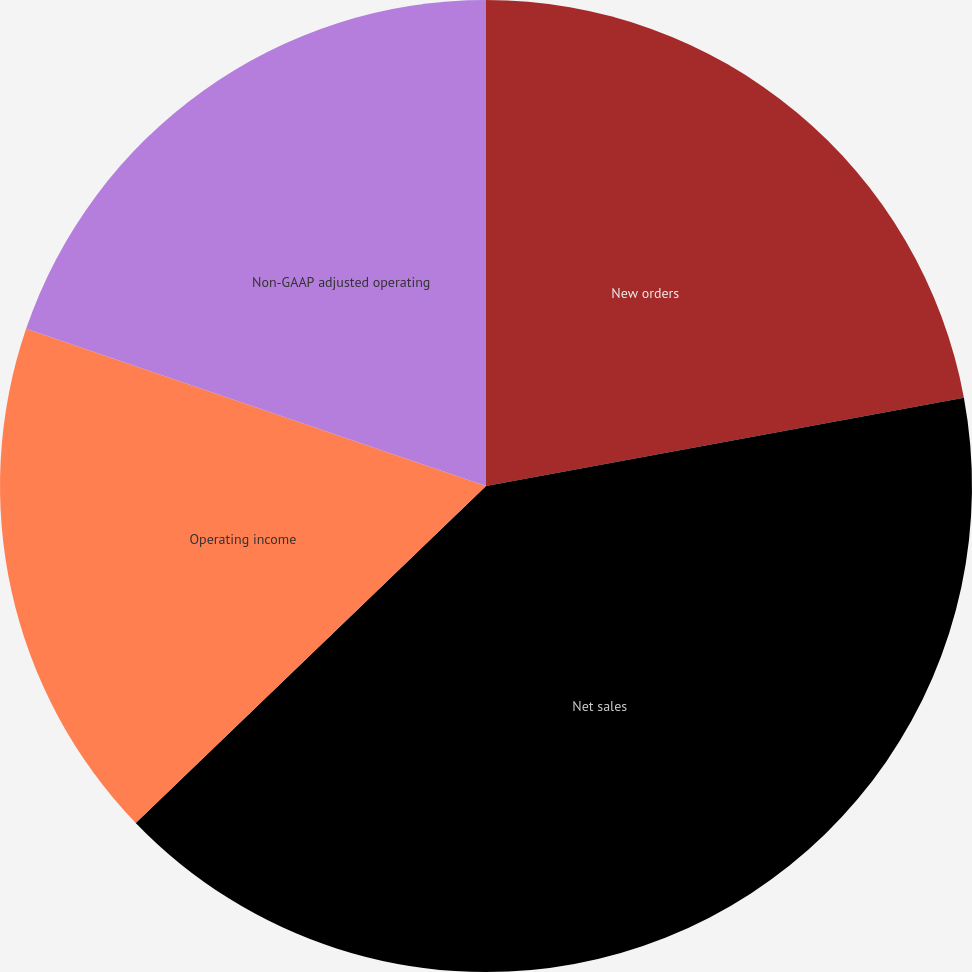Convert chart. <chart><loc_0><loc_0><loc_500><loc_500><pie_chart><fcel>New orders<fcel>Net sales<fcel>Operating income<fcel>Non-GAAP adjusted operating<nl><fcel>22.09%<fcel>40.72%<fcel>17.43%<fcel>19.76%<nl></chart> 